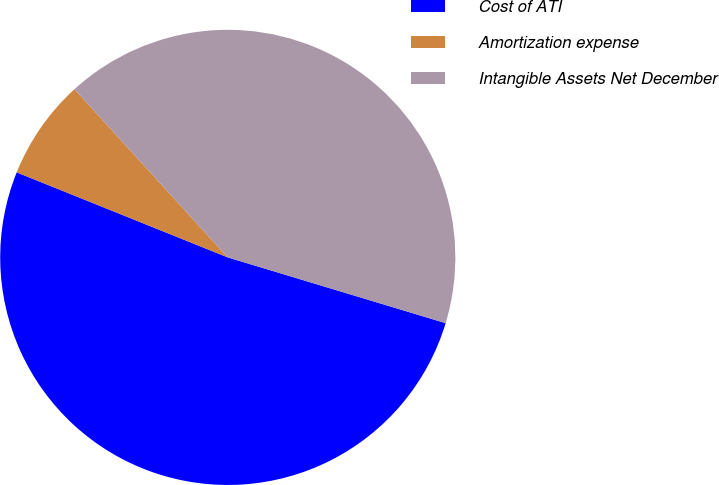<chart> <loc_0><loc_0><loc_500><loc_500><pie_chart><fcel>Cost of ATI<fcel>Amortization expense<fcel>Intangible Assets Net December<nl><fcel>51.43%<fcel>7.14%<fcel>41.43%<nl></chart> 